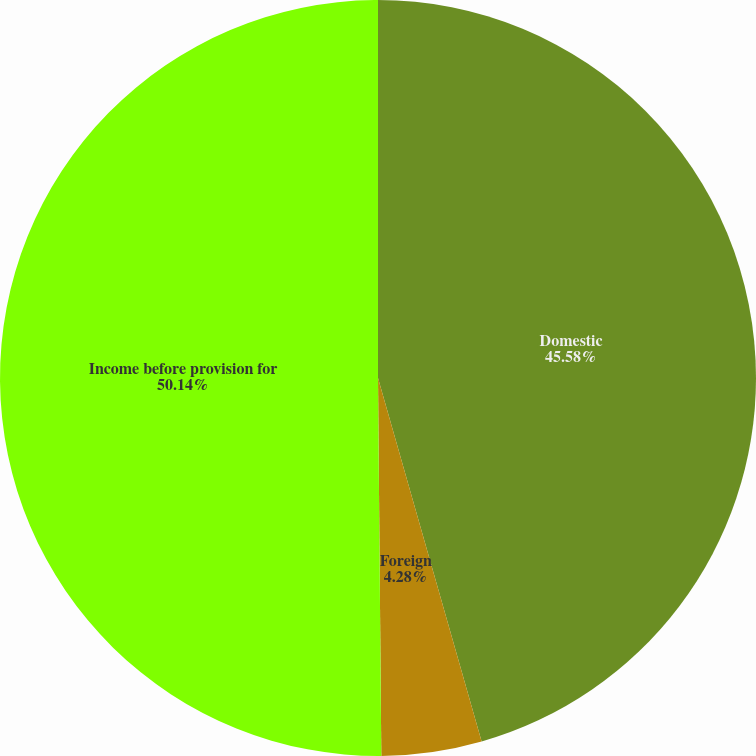Convert chart. <chart><loc_0><loc_0><loc_500><loc_500><pie_chart><fcel>Domestic<fcel>Foreign<fcel>Income before provision for<nl><fcel>45.58%<fcel>4.28%<fcel>50.14%<nl></chart> 